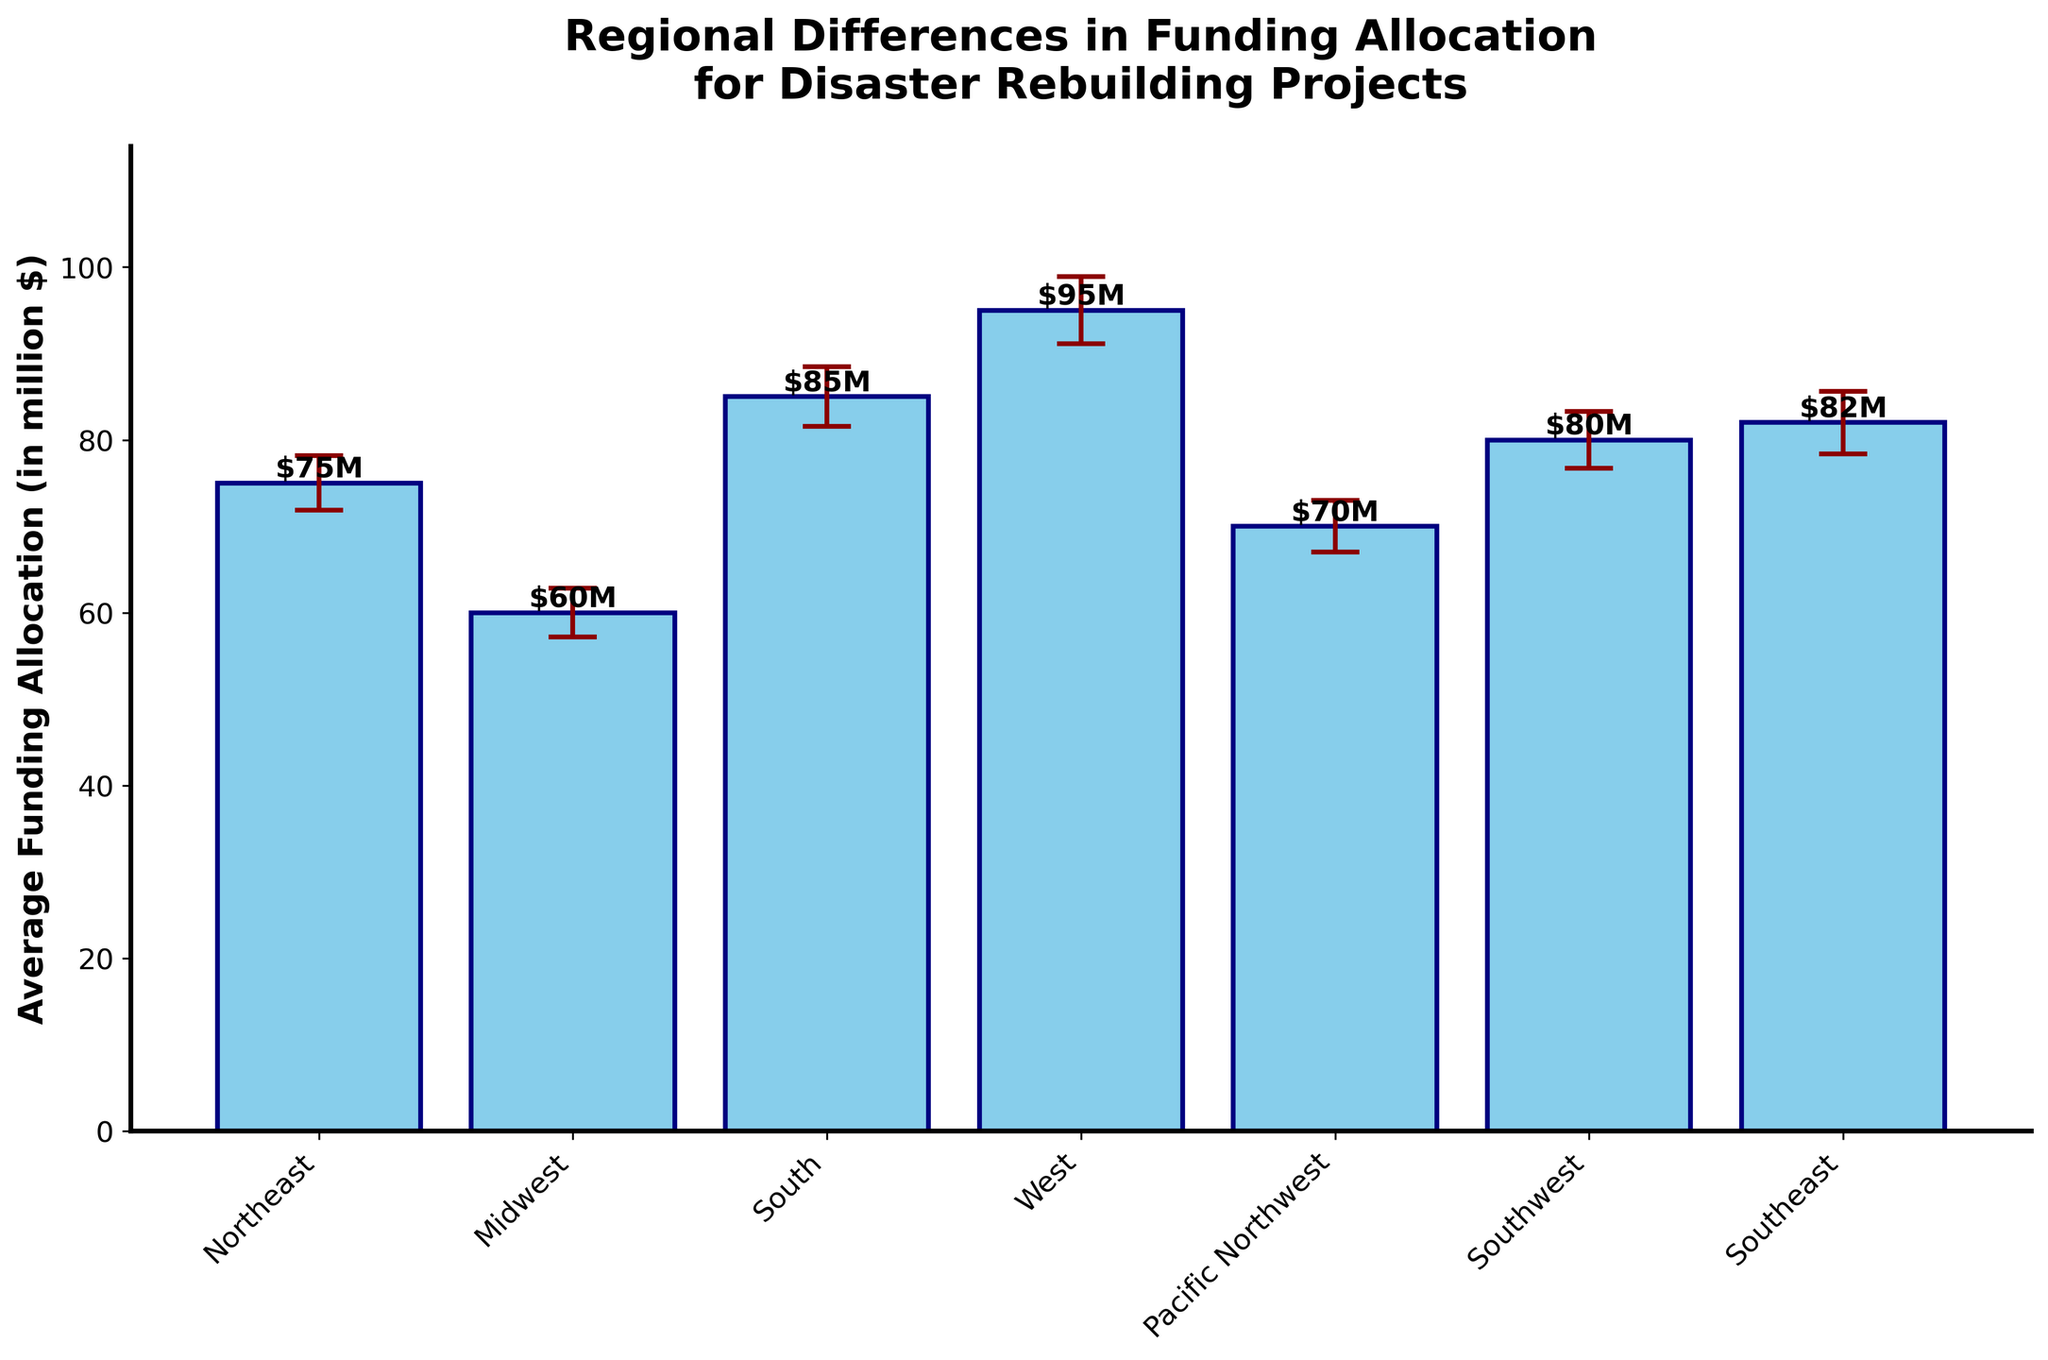What is the title of the chart? The title is displayed at the top of the chart, usually in bold and larger font size than other text elements.
Answer: Regional Differences in Funding Allocation for Disaster Rebuilding Projects How many regions are shown in the bar chart? Count the number of bars in the chart; each bar represents a different region.
Answer: Seven Which region has the highest average funding allocation? Identify the tallest bar on the chart as it represents the highest value.
Answer: West What is the average funding allocation for the Midwest region? Find the bar labeled "Midwest"; the number at the top of the bar denotes its value in million dollars.
Answer: $60M Which regions have an average funding allocation less than $70M? Observe the bars and compare their heights with the $70M level on the y-axis. Identify those that are below this level.
Answer: Midwest and Pacific Northwest What is the difference in average funding allocation between the South and the Southwest? Subtract the funding allocation of the Southwest from that of the South ($85M - $80M).
Answer: $5M Which region has the largest error bar and what does this represent? Identify the bar with the longest error lines extending above and below. This represents the highest variance in funding allocation.
Answer: West What is the combined average funding allocation for the Southeast and Northeast regions? Add the average funding allocations for Southeast and Northeast regions ($82M + $75M).
Answer: $157M Which two regions have the closest average funding allocations? Compare and identify the bars with the smallest difference in their heights. Compute their difference if needed.
Answer: Southeast and Southwest How does the variance in funding allocation compare between the Northeast and South regions? Compare the lengths of the error bars (error lines) for Northeast and South. The length of error bars represents the variance.
Answer: South has higher variance 